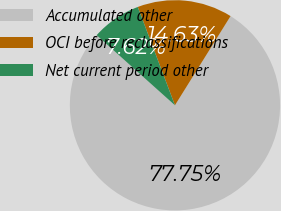Convert chart to OTSL. <chart><loc_0><loc_0><loc_500><loc_500><pie_chart><fcel>Accumulated other<fcel>OCI before reclassifications<fcel>Net current period other<nl><fcel>77.75%<fcel>14.63%<fcel>7.62%<nl></chart> 